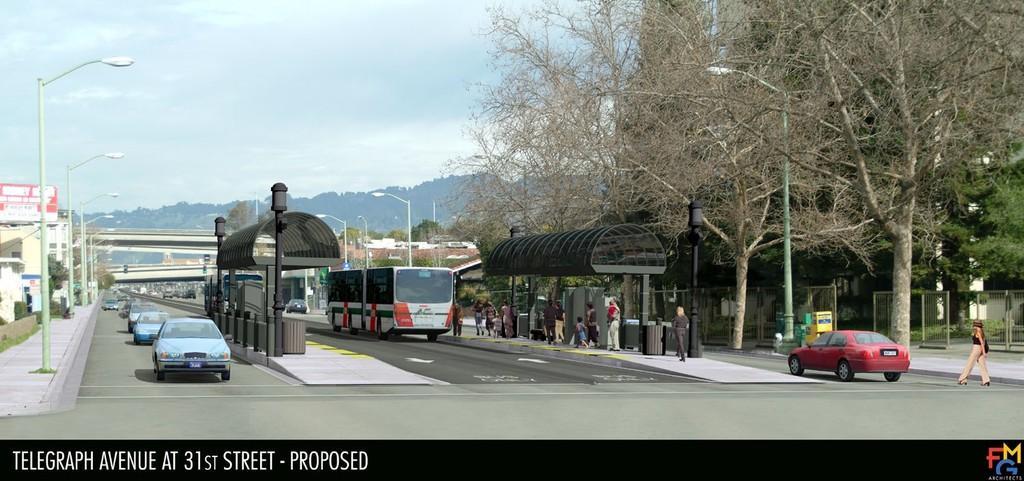Can you describe this image briefly? In this picture we can see a group of people are walking on the path and on the left side of the people there are some vehicles on the road and on the path there are poles with lights. Behind the vehicles there is a bridge, hoarding, trees, buildings and a cloudy sky. 